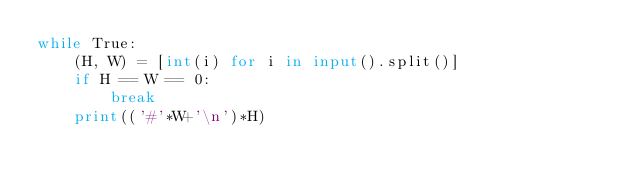Convert code to text. <code><loc_0><loc_0><loc_500><loc_500><_Python_>while True:
    (H, W) = [int(i) for i in input().split()]
    if H == W == 0:
        break
    print(('#'*W+'\n')*H)</code> 